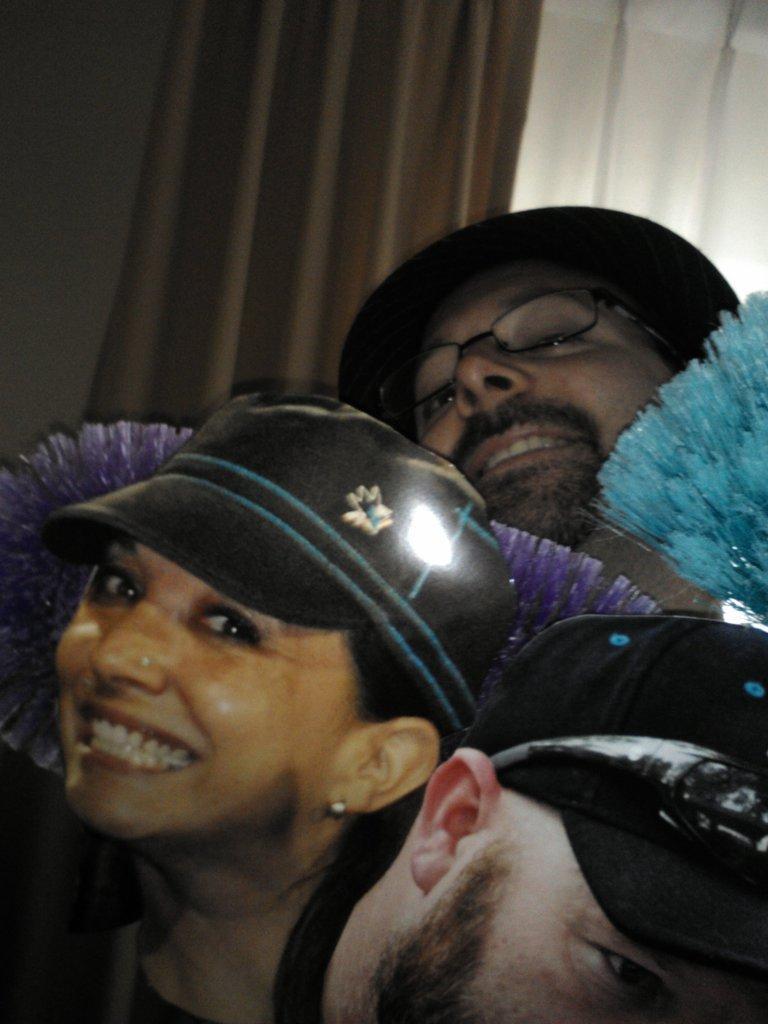Can you describe this image briefly? In the picture I can see three persons wearing caps and there are some other objects in between them and there is a curtain in the background. 